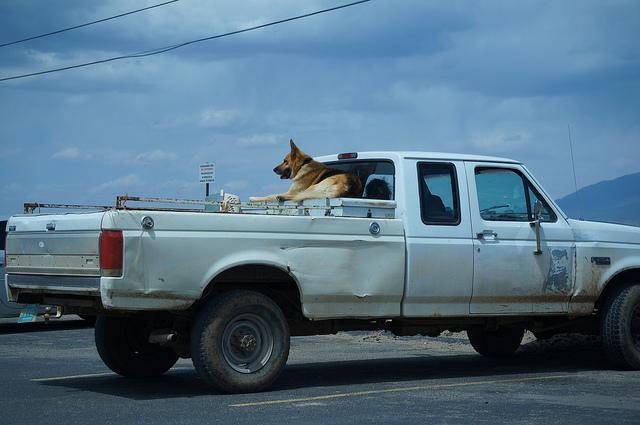Which truck does this dog's owner possess?
Choose the correct response and explain in the format: 'Answer: answer
Rationale: rationale.'
Options: Blue truck, semi truck, distant truck, white truck. Answer: white truck.
Rationale: The truck is white, and the dog is laying on the bed of the white truck. 